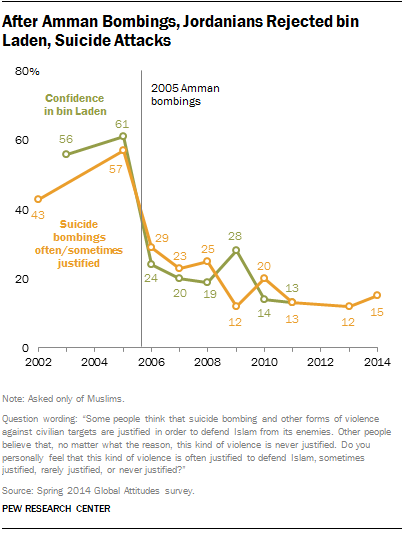Identify some key points in this picture. The median of the orange graph from 2002 to 2006 is smaller than the highest value of the green graph. The highest value of green in the graph is 61. 